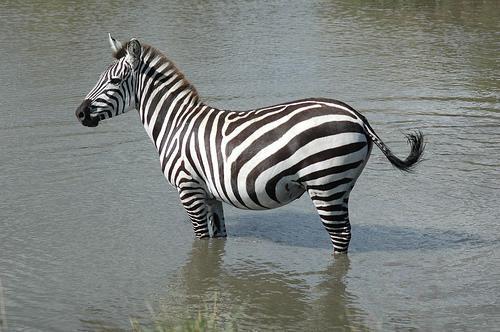How many animals are there?
Give a very brief answer. 1. 